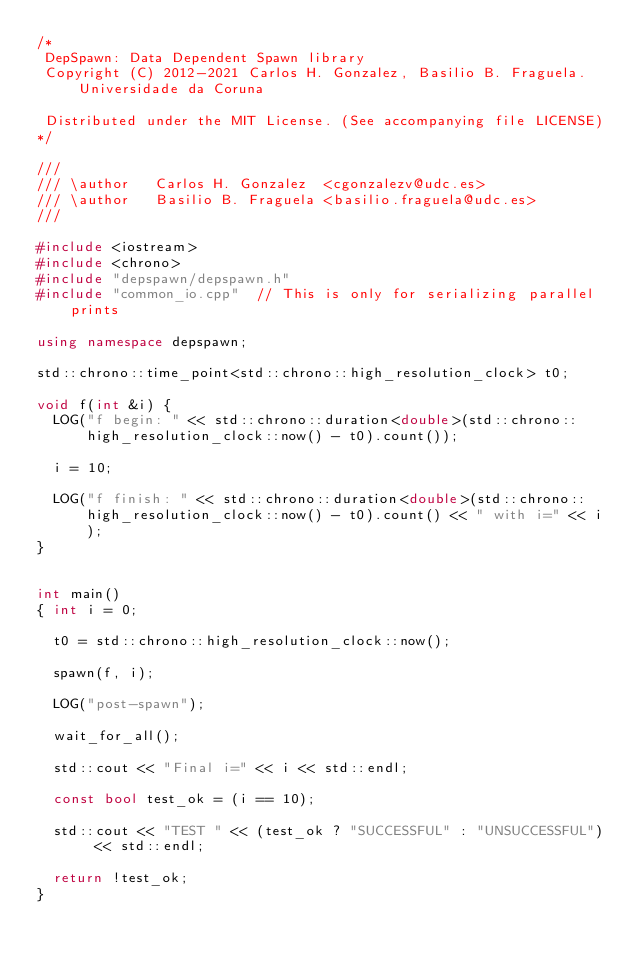<code> <loc_0><loc_0><loc_500><loc_500><_C++_>/*
 DepSpawn: Data Dependent Spawn library
 Copyright (C) 2012-2021 Carlos H. Gonzalez, Basilio B. Fraguela. Universidade da Coruna
 
 Distributed under the MIT License. (See accompanying file LICENSE)
*/

///
/// \author   Carlos H. Gonzalez  <cgonzalezv@udc.es>
/// \author   Basilio B. Fraguela <basilio.fraguela@udc.es>
///

#include <iostream>
#include <chrono>
#include "depspawn/depspawn.h"
#include "common_io.cpp"  // This is only for serializing parallel prints

using namespace depspawn;

std::chrono::time_point<std::chrono::high_resolution_clock> t0;

void f(int &i) {  
  LOG("f begin: " << std::chrono::duration<double>(std::chrono::high_resolution_clock::now() - t0).count());

  i = 10;
  
  LOG("f finish: " << std::chrono::duration<double>(std::chrono::high_resolution_clock::now() - t0).count() << " with i=" << i);
}


int main()
{ int i = 0;

  t0 = std::chrono::high_resolution_clock::now();
  
  spawn(f, i);
  
  LOG("post-spawn");
  
  wait_for_all();

  std::cout << "Final i=" << i << std::endl;

  const bool test_ok = (i == 10);
  
  std::cout << "TEST " << (test_ok ? "SUCCESSFUL" : "UNSUCCESSFUL") << std::endl;
  
  return !test_ok;
}
</code> 